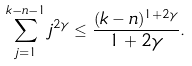Convert formula to latex. <formula><loc_0><loc_0><loc_500><loc_500>\sum _ { j = 1 } ^ { k - n - 1 } j ^ { 2 \gamma } \leq \frac { ( k - n ) ^ { 1 + 2 \gamma } } { 1 + 2 \gamma } .</formula> 